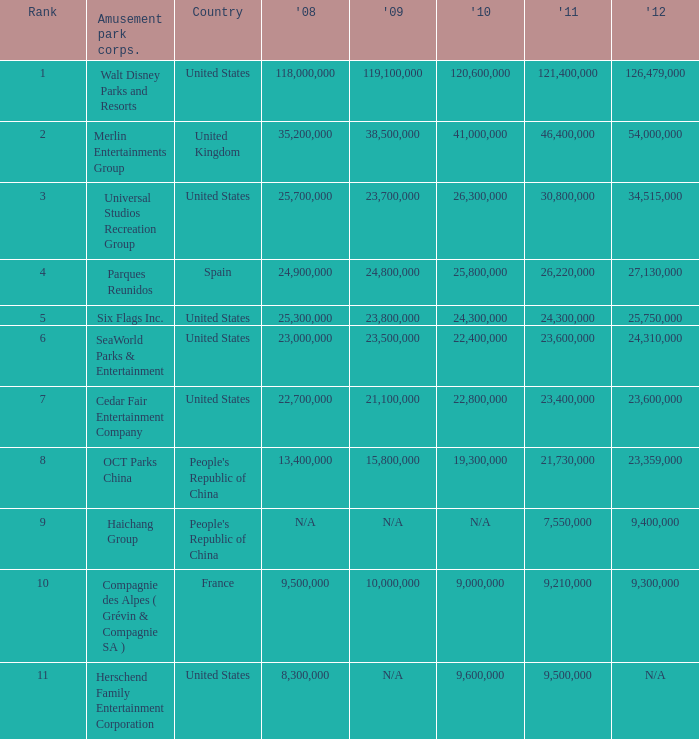What is the Rank listed for the attendance of 2010 of 9,000,000 and 2011 larger than 9,210,000? None. 